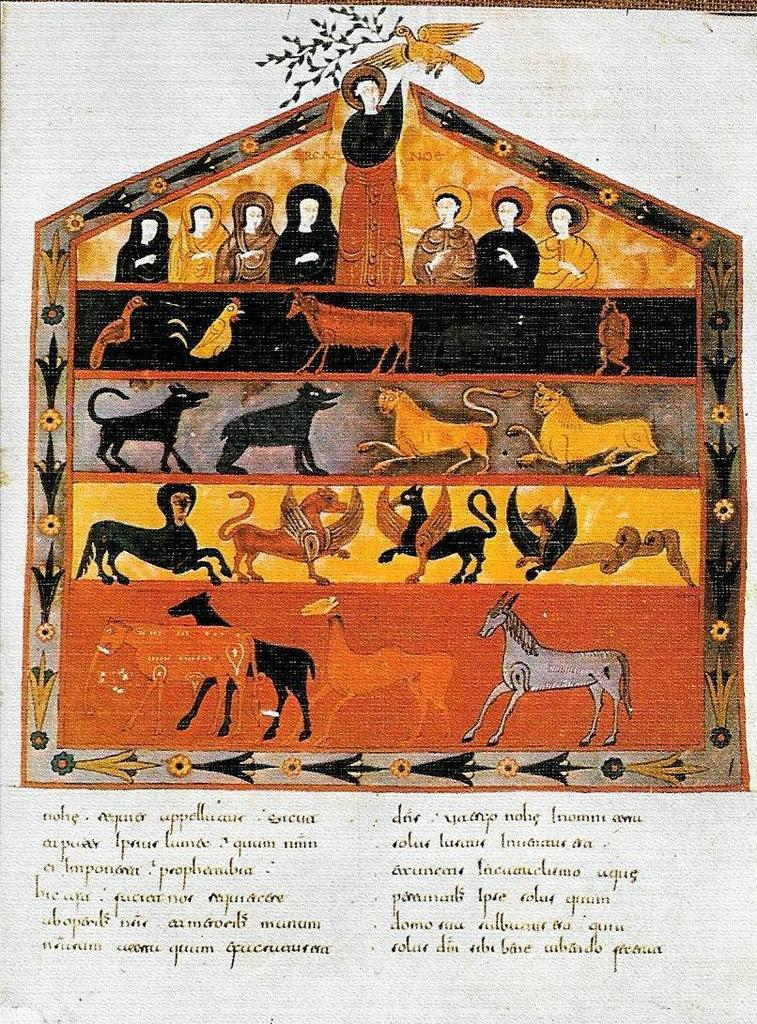What type of images are featured on the poster? The poster contains paintings of animals and persons. Can you describe one of the animal paintings on the poster? Yes, there is a painting of a bird on the poster. What is the color of the background on the poster? The background of the poster is white in color. Are there any texts on the poster? Yes, there are texts on the poster. How many knees are visible in the paintings of persons on the poster? There is no mention of knees in the paintings of persons on the poster, so it is not possible to determine the number of knees visible. Is there a dog featured in any of the paintings on the poster? There is no mention of a dog in any of the paintings on the poster. 